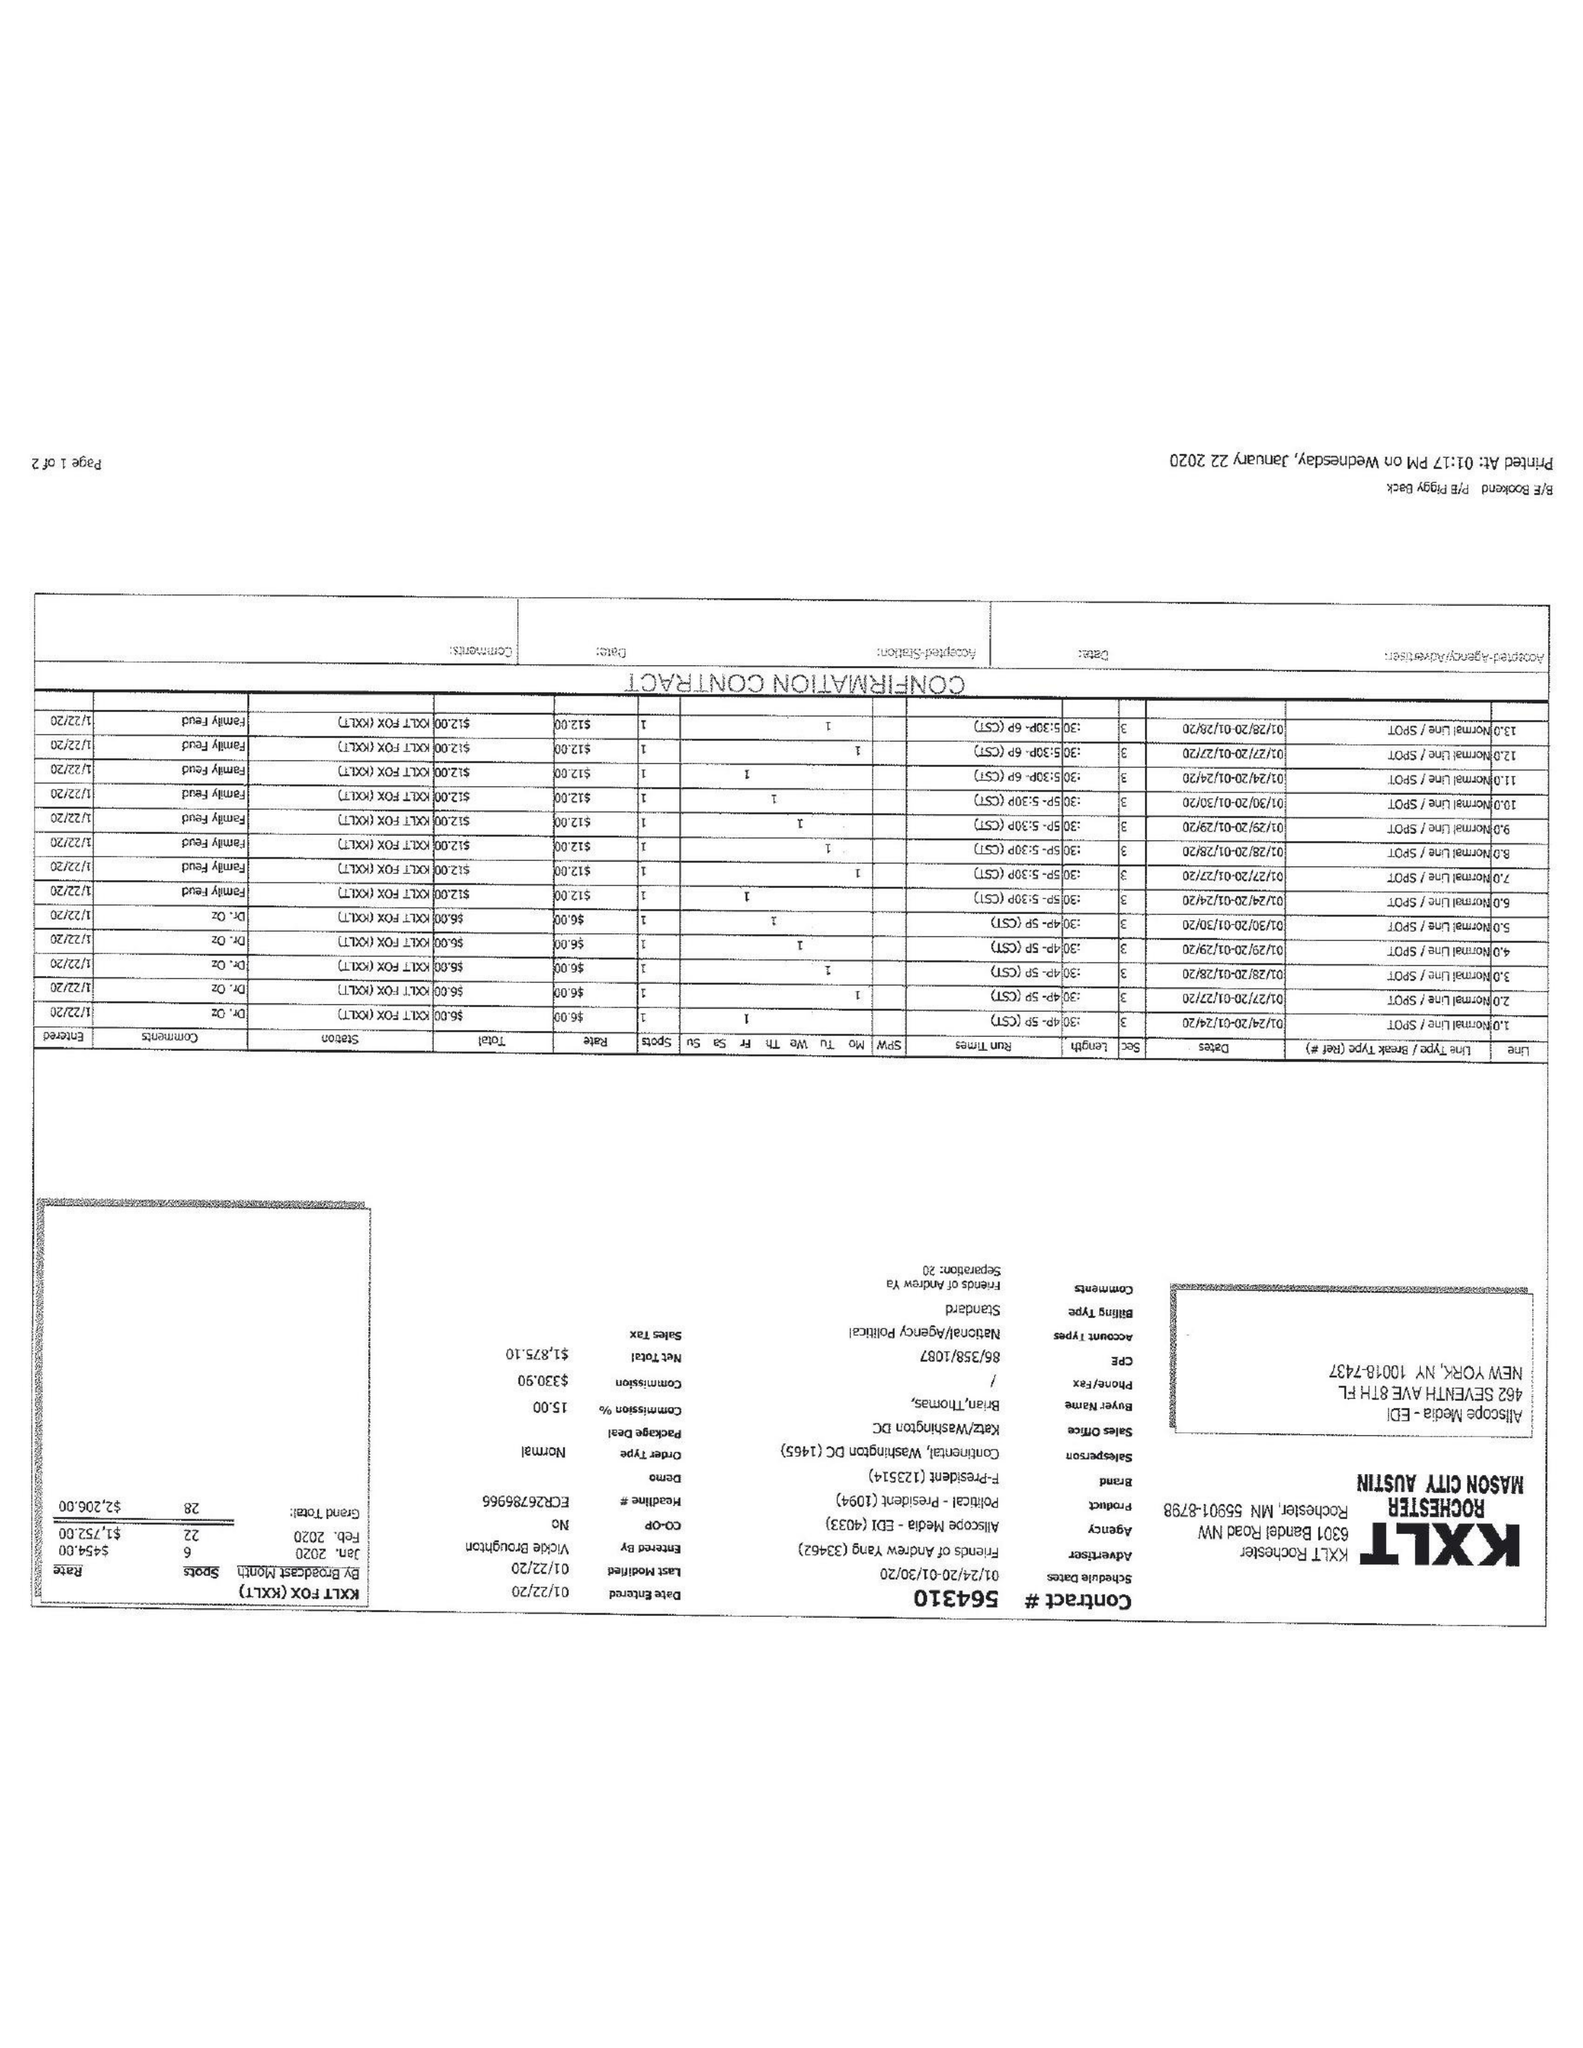What is the value for the advertiser?
Answer the question using a single word or phrase. FRIENDS OF ANDREW YANG 